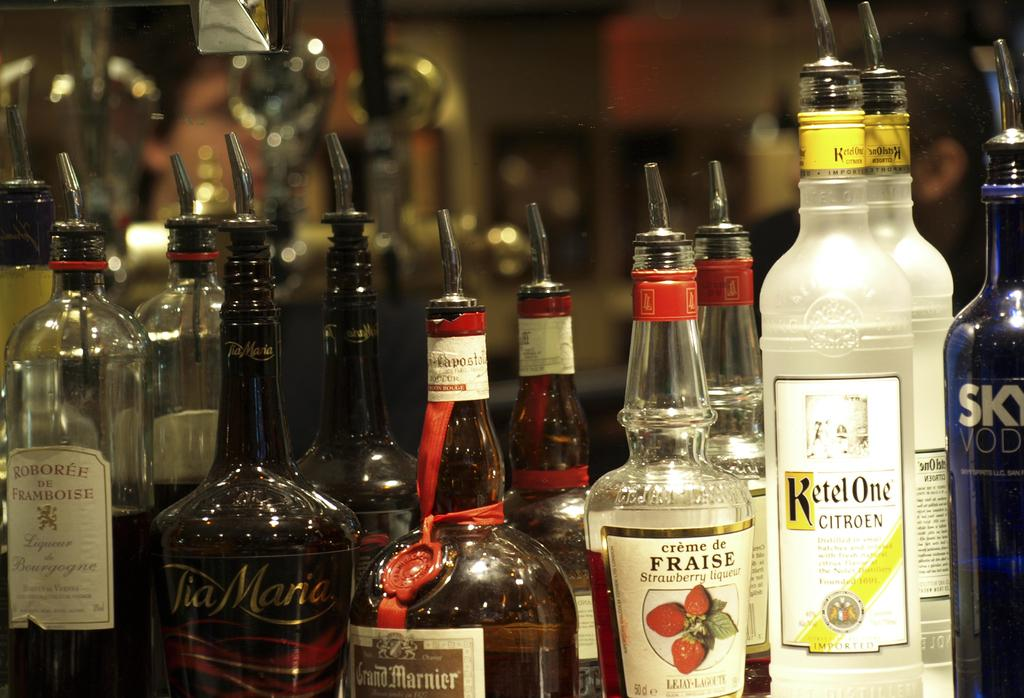<image>
Present a compact description of the photo's key features. Several different brands and types of liquor such as creme liquors and vodka are lined up in front of a mirror, in a bar. 